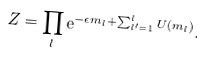Convert formula to latex. <formula><loc_0><loc_0><loc_500><loc_500>Z = \prod _ { l } \mathrm e ^ { - \epsilon m _ { l } + \sum _ { l ^ { \prime } = 1 } ^ { l } U ( m _ { l } ) } .</formula> 